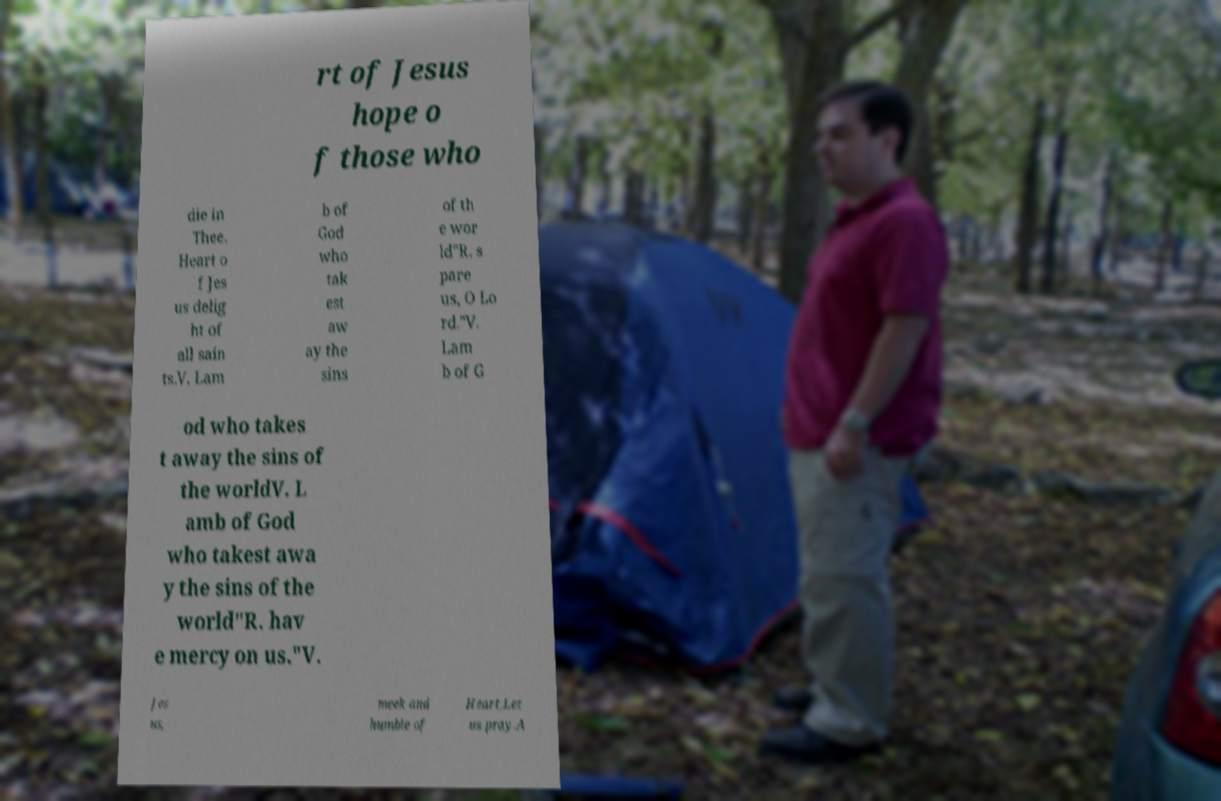I need the written content from this picture converted into text. Can you do that? rt of Jesus hope o f those who die in Thee. Heart o f Jes us delig ht of all sain ts.V. Lam b of God who tak est aw ay the sins of th e wor ld"R. s pare us, O Lo rd."V. Lam b of G od who takes t away the sins of the worldV. L amb of God who takest awa y the sins of the world"R. hav e mercy on us."V. Jes us, meek and humble of Heart,Let us pray.A 